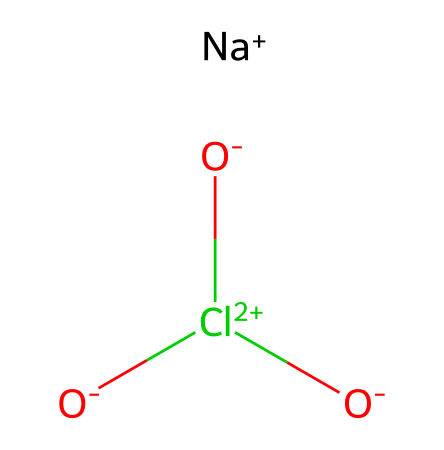What is the molecular formula of sodium chlorate? By analyzing the SMILES representation, we identify one sodium (Na) atom, three oxygen (O) atoms, and one chlorine (Cl) atom, giving us the formula NaClO3.
Answer: NaClO3 How many oxygen atoms are in this compound? The SMILES indicates there are three oxygen atoms attached to the chlorine atom in the structure.
Answer: 3 What type of chemical is sodium chlorate? Sodium chlorate is classified as an oxidizer due to its ability to release oxygen readily and support combustion.
Answer: oxidizer What is the oxidation state of chlorine in sodium chlorate? In NaClO3, chlorine has an oxidation state of +5, as calculated by considering the overall charge balance of the compound where Na is +1 and the three oxygens contribute -6.
Answer: +5 What role does sodium chlorate play in smoke grenade formulations? Sodium chlorate acts as an oxidizing agent in smoke grenades, facilitating the combustion of fuels and producing smoke when mixed with particulate matter.
Answer: oxidizing agent How many total atoms are present in sodium chlorate? Counting from the molecular formula NaClO3, the total number of atoms is five: one sodium, one chlorine, and three oxygen atoms.
Answer: 5 